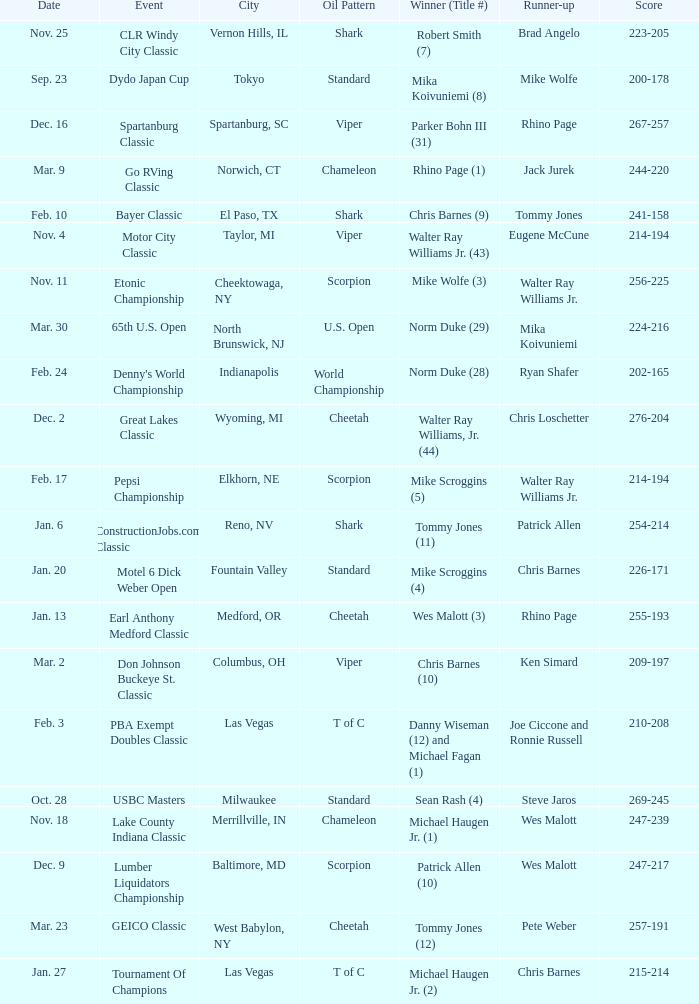Which Oil Pattern has a Winner (Title #) of mike wolfe (3)? Scorpion. 